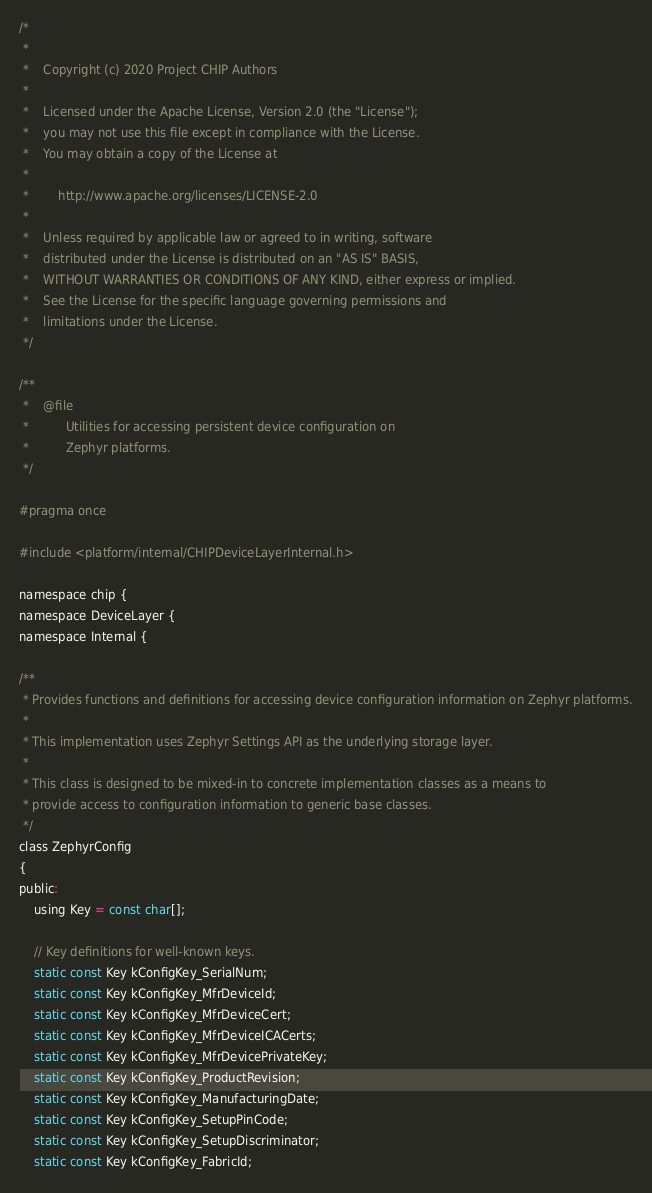Convert code to text. <code><loc_0><loc_0><loc_500><loc_500><_C_>/*
 *
 *    Copyright (c) 2020 Project CHIP Authors
 *
 *    Licensed under the Apache License, Version 2.0 (the "License");
 *    you may not use this file except in compliance with the License.
 *    You may obtain a copy of the License at
 *
 *        http://www.apache.org/licenses/LICENSE-2.0
 *
 *    Unless required by applicable law or agreed to in writing, software
 *    distributed under the License is distributed on an "AS IS" BASIS,
 *    WITHOUT WARRANTIES OR CONDITIONS OF ANY KIND, either express or implied.
 *    See the License for the specific language governing permissions and
 *    limitations under the License.
 */

/**
 *    @file
 *          Utilities for accessing persistent device configuration on
 *          Zephyr platforms.
 */

#pragma once

#include <platform/internal/CHIPDeviceLayerInternal.h>

namespace chip {
namespace DeviceLayer {
namespace Internal {

/**
 * Provides functions and definitions for accessing device configuration information on Zephyr platforms.
 *
 * This implementation uses Zephyr Settings API as the underlying storage layer.
 *
 * This class is designed to be mixed-in to concrete implementation classes as a means to
 * provide access to configuration information to generic base classes.
 */
class ZephyrConfig
{
public:
    using Key = const char[];

    // Key definitions for well-known keys.
    static const Key kConfigKey_SerialNum;
    static const Key kConfigKey_MfrDeviceId;
    static const Key kConfigKey_MfrDeviceCert;
    static const Key kConfigKey_MfrDeviceICACerts;
    static const Key kConfigKey_MfrDevicePrivateKey;
    static const Key kConfigKey_ProductRevision;
    static const Key kConfigKey_ManufacturingDate;
    static const Key kConfigKey_SetupPinCode;
    static const Key kConfigKey_SetupDiscriminator;
    static const Key kConfigKey_FabricId;</code> 